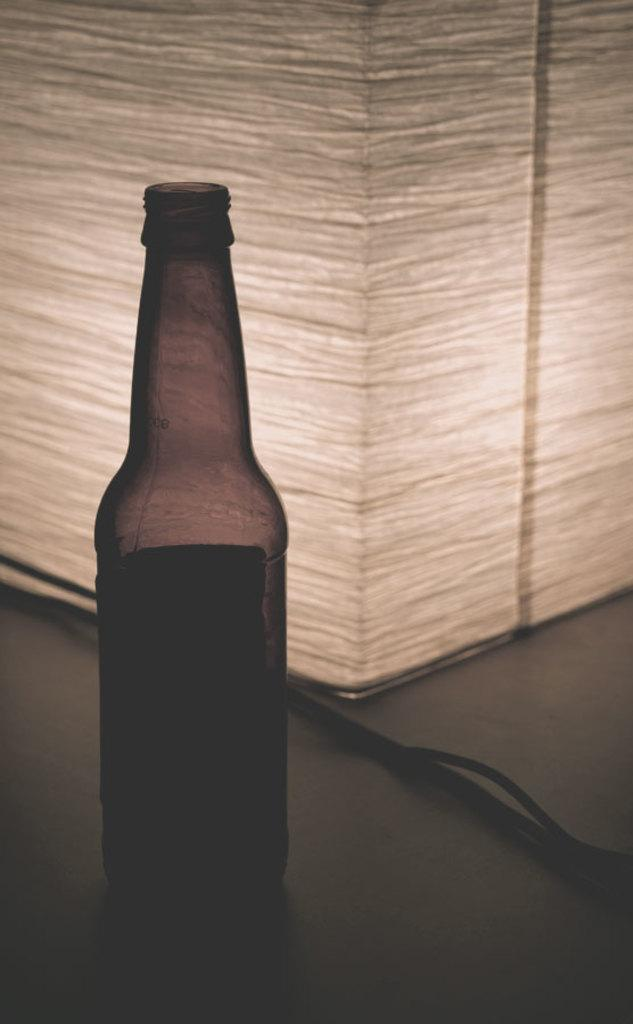What can be seen in the image that is typically used for holding liquids? There is a bottle in the image that is typically used for holding liquids. Where is the bottle located in the image? The bottle is on a surface in the image. What else can be seen in the image besides the bottle? There is a wire visible in the image. Can you describe the object behind the bottle? There is an object behind the bottle, but its specific details are not mentioned in the provided facts. What type of toothpaste is being used to paint the coat in the image? There is no toothpaste or coat present in the image. 